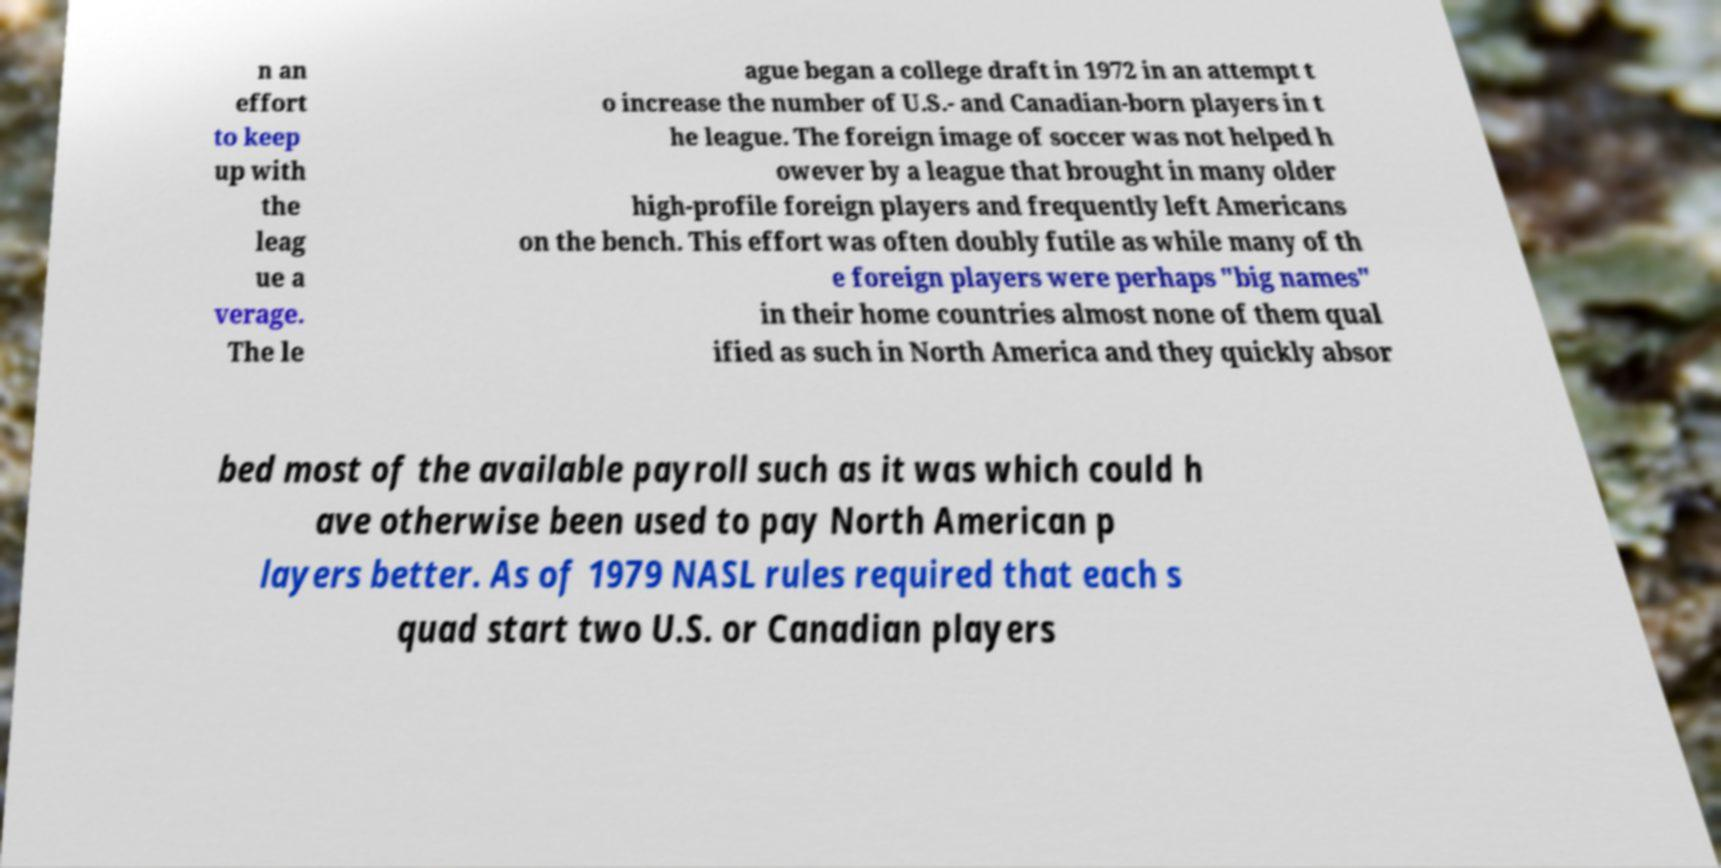Please identify and transcribe the text found in this image. n an effort to keep up with the leag ue a verage. The le ague began a college draft in 1972 in an attempt t o increase the number of U.S.- and Canadian-born players in t he league. The foreign image of soccer was not helped h owever by a league that brought in many older high-profile foreign players and frequently left Americans on the bench. This effort was often doubly futile as while many of th e foreign players were perhaps "big names" in their home countries almost none of them qual ified as such in North America and they quickly absor bed most of the available payroll such as it was which could h ave otherwise been used to pay North American p layers better. As of 1979 NASL rules required that each s quad start two U.S. or Canadian players 